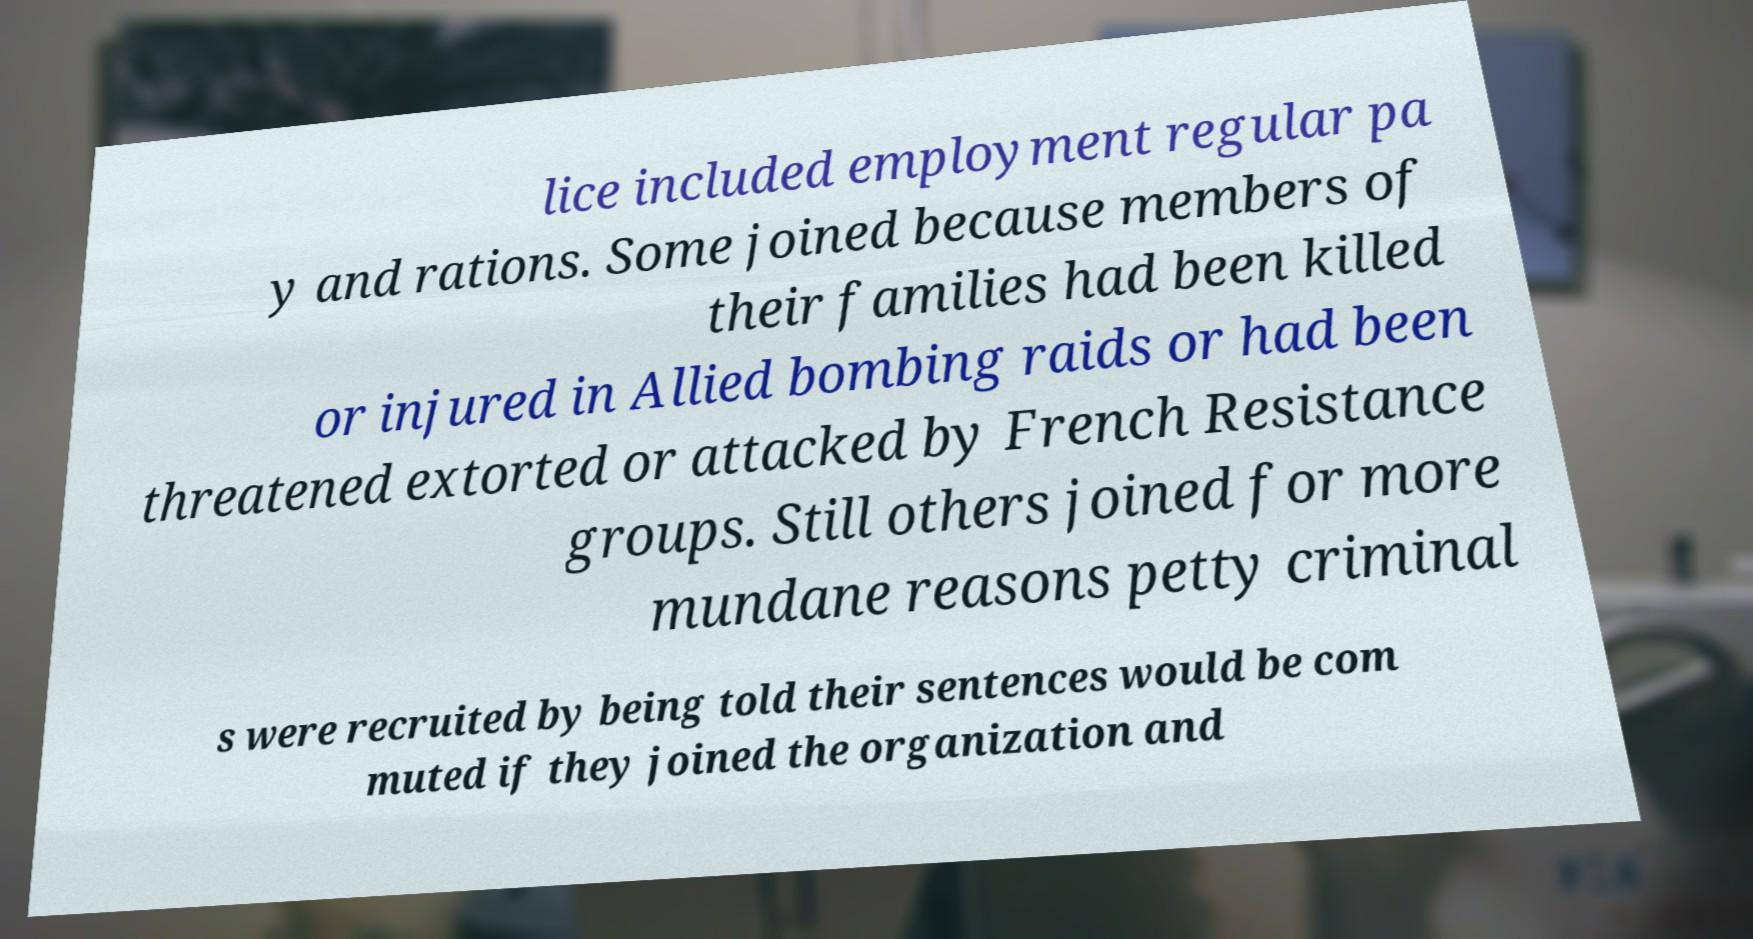There's text embedded in this image that I need extracted. Can you transcribe it verbatim? lice included employment regular pa y and rations. Some joined because members of their families had been killed or injured in Allied bombing raids or had been threatened extorted or attacked by French Resistance groups. Still others joined for more mundane reasons petty criminal s were recruited by being told their sentences would be com muted if they joined the organization and 